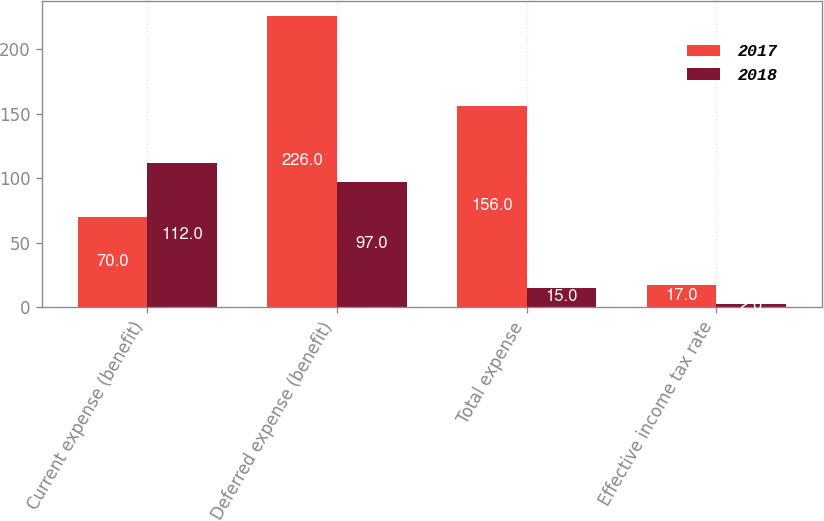Convert chart. <chart><loc_0><loc_0><loc_500><loc_500><stacked_bar_chart><ecel><fcel>Current expense (benefit)<fcel>Deferred expense (benefit)<fcel>Total expense<fcel>Effective income tax rate<nl><fcel>2017<fcel>70<fcel>226<fcel>156<fcel>17<nl><fcel>2018<fcel>112<fcel>97<fcel>15<fcel>2<nl></chart> 